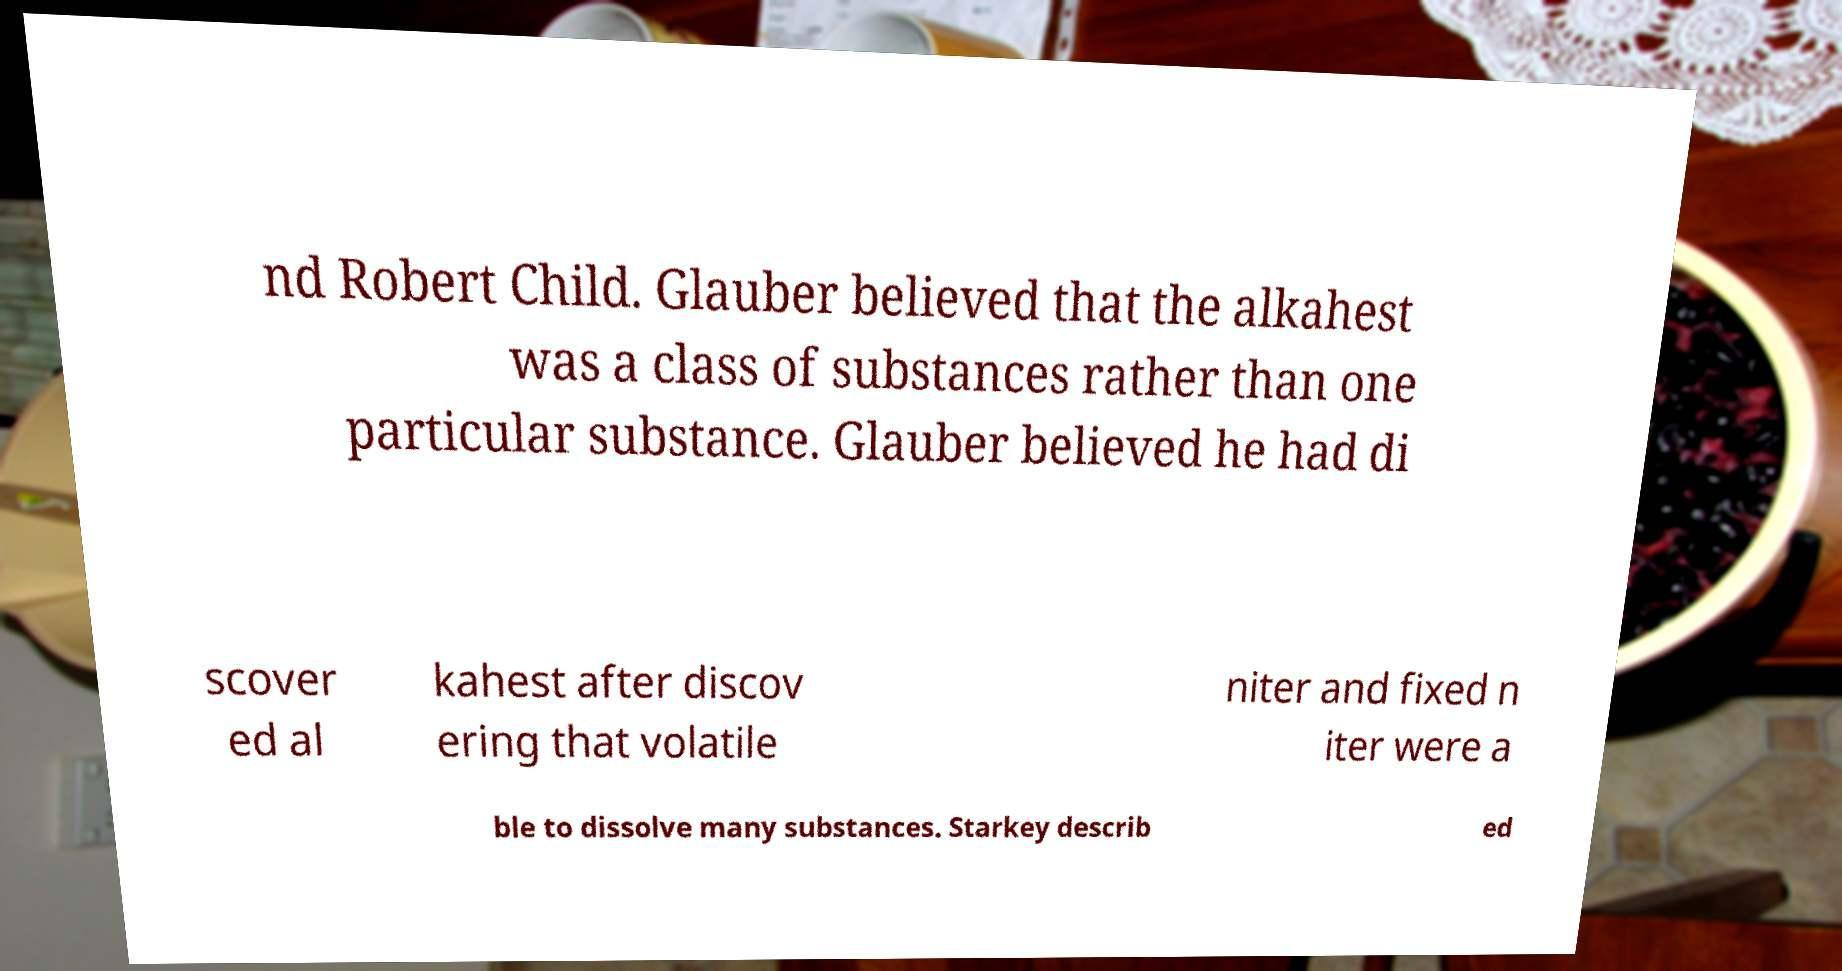For documentation purposes, I need the text within this image transcribed. Could you provide that? nd Robert Child. Glauber believed that the alkahest was a class of substances rather than one particular substance. Glauber believed he had di scover ed al kahest after discov ering that volatile niter and fixed n iter were a ble to dissolve many substances. Starkey describ ed 